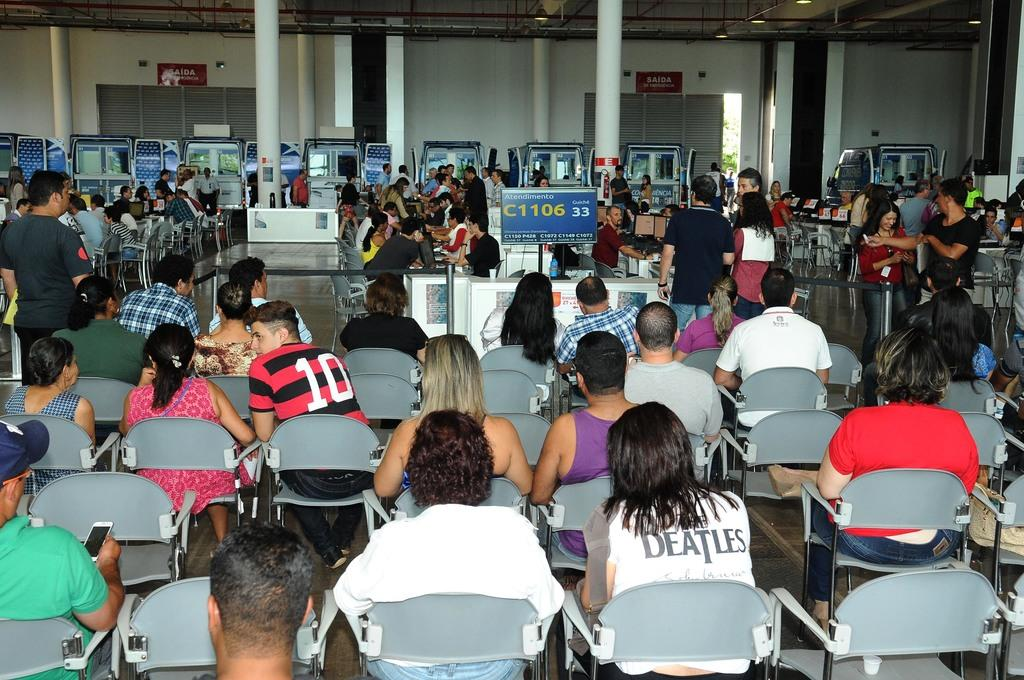How many people are in the image? There are people in the image, but the exact number is not specified. What are the people in the image doing? Some people are sitting, while others are standing. What can be seen in the background of the image? There is a banner, a pillow, a machine, and a wall in the background. What type of chain is being used by the sister in the image? There is no mention of a sister or a chain in the image, so this question cannot be answered. 